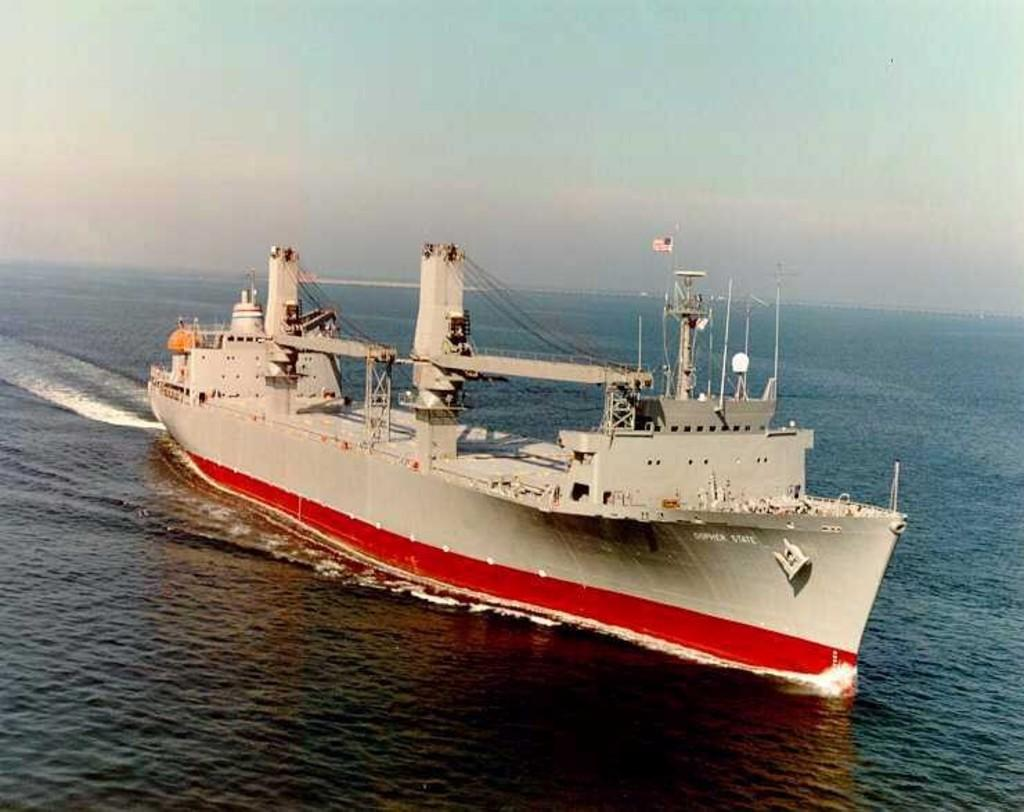What is the main subject of the image? There is a ship in the image. Where is the ship located? The ship is on the sea. What can be seen in the background of the image? The sky is visible in the background of the image. What type of quilt is being used to sail the ship in the image? There is no quilt present in the image, and quilts are not used for sailing ships. 